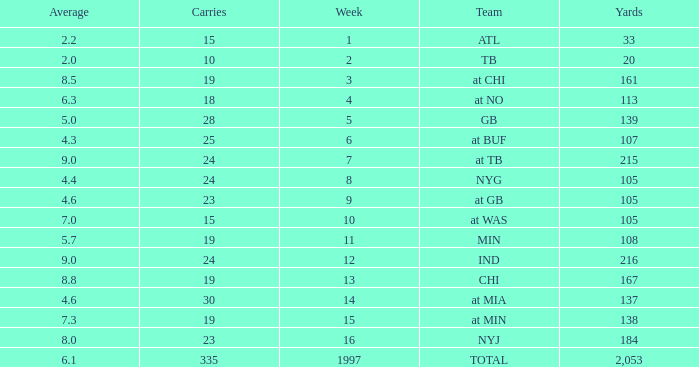Which Yards have Carries smaller than 23, and a Team of at chi, and an Average smaller than 8.5? None. 